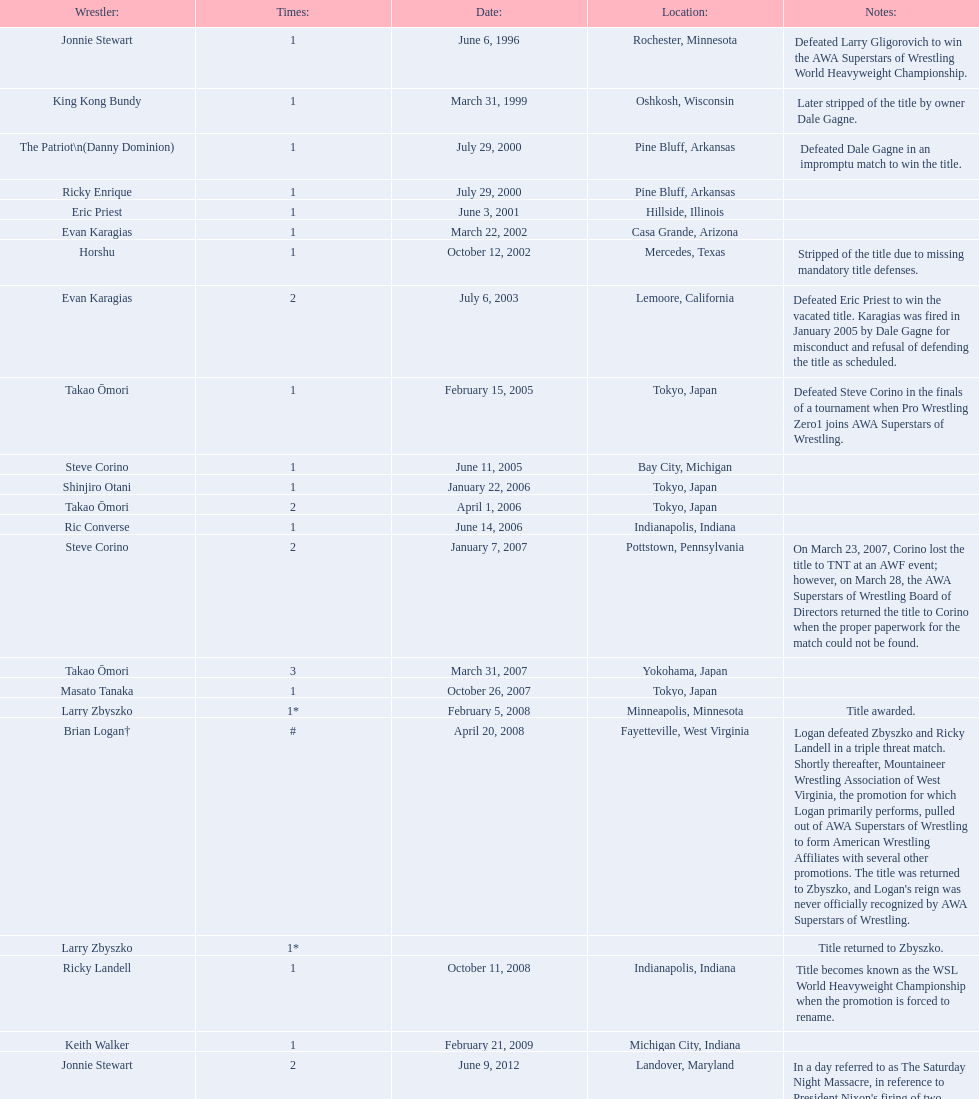Who is the last wrestler to hold the title? The Honky Tonk Man. 